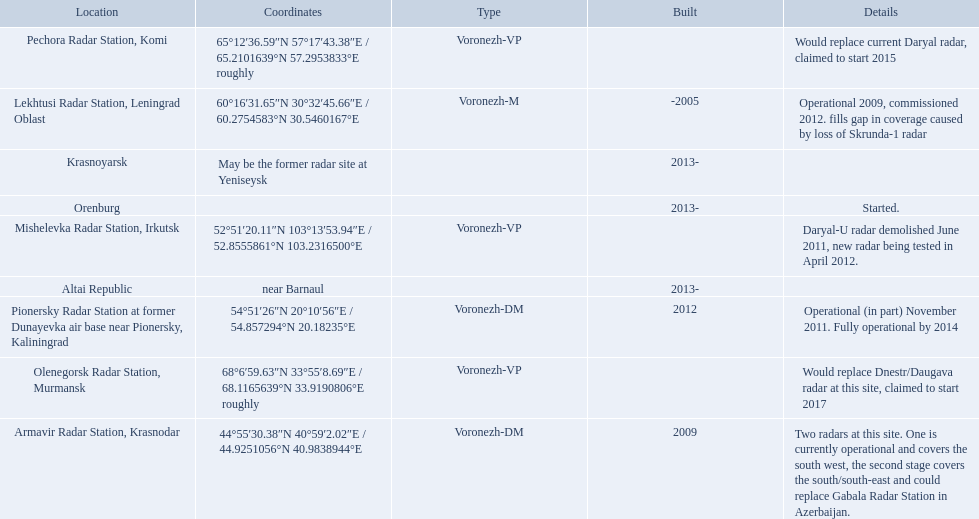Which voronezh radar has already started? Orenburg. Which radar would replace dnestr/daugava? Olenegorsk Radar Station, Murmansk. Which radar started in 2015? Pechora Radar Station, Komi. 